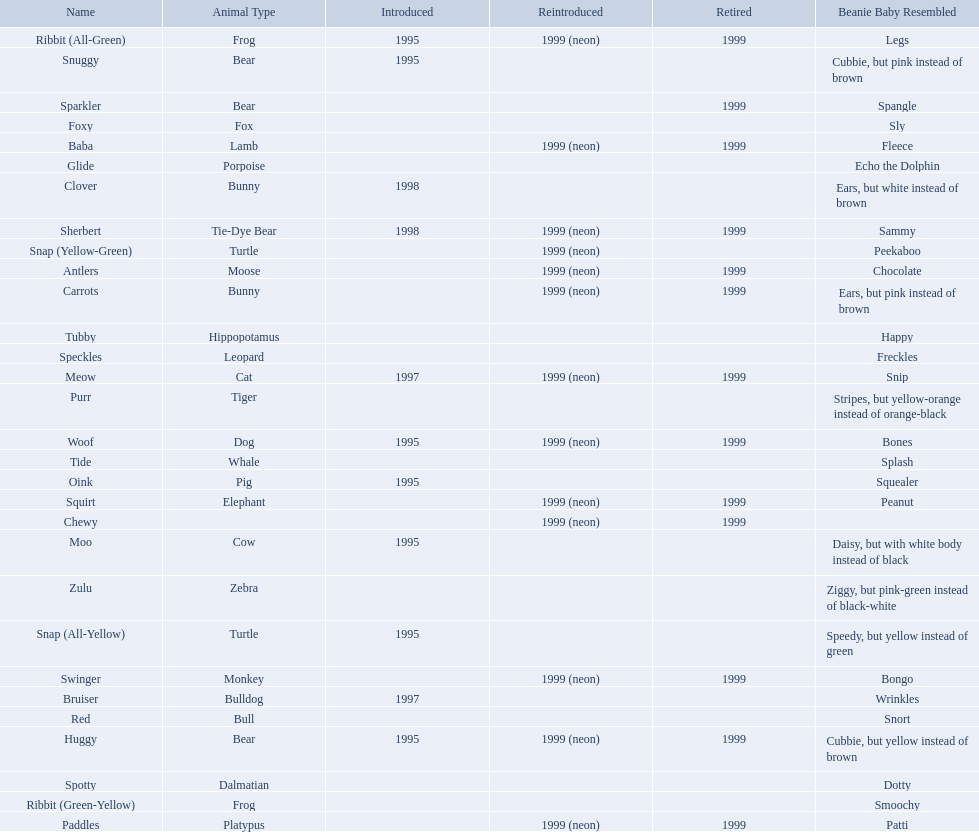What are the types of pillow pal animals? Antlers, Moose, Lamb, Bulldog, Bunny, , Bunny, Fox, Porpoise, Bear, Cat, Cow, Pig, Platypus, Tiger, Bull, Frog, Frog, Tie-Dye Bear, Turtle, Turtle, Bear, Bear, Leopard, Dalmatian, Elephant, Monkey, Whale, Hippopotamus, Dog, Zebra. Of those, which is a dalmatian? Dalmatian. What is the name of the dalmatian? Spotty. 